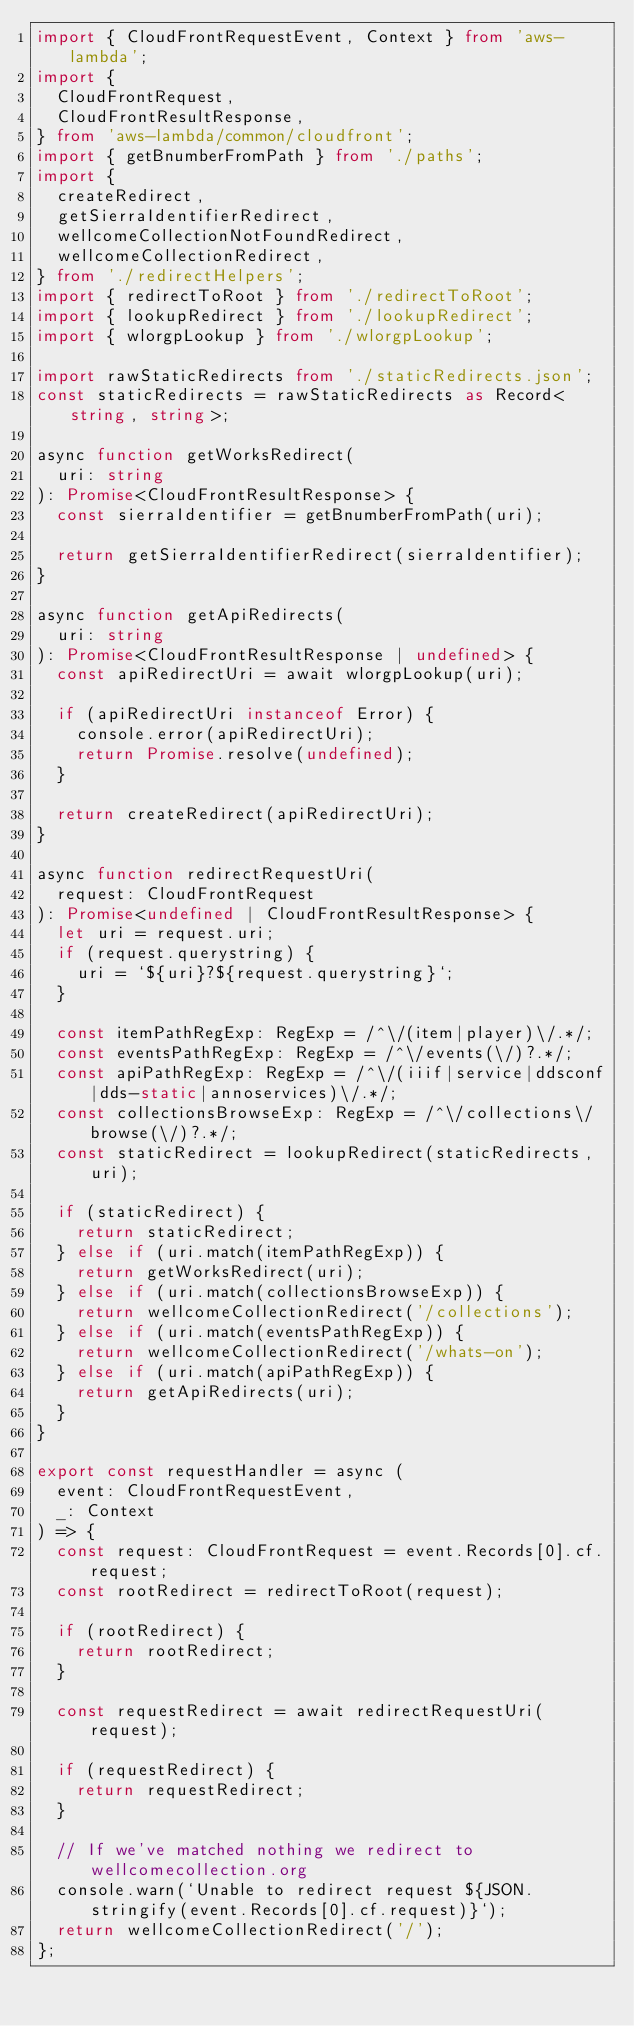Convert code to text. <code><loc_0><loc_0><loc_500><loc_500><_TypeScript_>import { CloudFrontRequestEvent, Context } from 'aws-lambda';
import {
  CloudFrontRequest,
  CloudFrontResultResponse,
} from 'aws-lambda/common/cloudfront';
import { getBnumberFromPath } from './paths';
import {
  createRedirect,
  getSierraIdentifierRedirect,
  wellcomeCollectionNotFoundRedirect,
  wellcomeCollectionRedirect,
} from './redirectHelpers';
import { redirectToRoot } from './redirectToRoot';
import { lookupRedirect } from './lookupRedirect';
import { wlorgpLookup } from './wlorgpLookup';

import rawStaticRedirects from './staticRedirects.json';
const staticRedirects = rawStaticRedirects as Record<string, string>;

async function getWorksRedirect(
  uri: string
): Promise<CloudFrontResultResponse> {
  const sierraIdentifier = getBnumberFromPath(uri);

  return getSierraIdentifierRedirect(sierraIdentifier);
}

async function getApiRedirects(
  uri: string
): Promise<CloudFrontResultResponse | undefined> {
  const apiRedirectUri = await wlorgpLookup(uri);

  if (apiRedirectUri instanceof Error) {
    console.error(apiRedirectUri);
    return Promise.resolve(undefined);
  }

  return createRedirect(apiRedirectUri);
}

async function redirectRequestUri(
  request: CloudFrontRequest
): Promise<undefined | CloudFrontResultResponse> {
  let uri = request.uri;
  if (request.querystring) {
    uri = `${uri}?${request.querystring}`;
  }

  const itemPathRegExp: RegExp = /^\/(item|player)\/.*/;
  const eventsPathRegExp: RegExp = /^\/events(\/)?.*/;
  const apiPathRegExp: RegExp = /^\/(iiif|service|ddsconf|dds-static|annoservices)\/.*/;
  const collectionsBrowseExp: RegExp = /^\/collections\/browse(\/)?.*/;
  const staticRedirect = lookupRedirect(staticRedirects, uri);

  if (staticRedirect) {
    return staticRedirect;
  } else if (uri.match(itemPathRegExp)) {
    return getWorksRedirect(uri);
  } else if (uri.match(collectionsBrowseExp)) {
    return wellcomeCollectionRedirect('/collections');
  } else if (uri.match(eventsPathRegExp)) {
    return wellcomeCollectionRedirect('/whats-on');
  } else if (uri.match(apiPathRegExp)) {
    return getApiRedirects(uri);
  }
}

export const requestHandler = async (
  event: CloudFrontRequestEvent,
  _: Context
) => {
  const request: CloudFrontRequest = event.Records[0].cf.request;
  const rootRedirect = redirectToRoot(request);

  if (rootRedirect) {
    return rootRedirect;
  }

  const requestRedirect = await redirectRequestUri(request);

  if (requestRedirect) {
    return requestRedirect;
  }

  // If we've matched nothing we redirect to wellcomecollection.org
  console.warn(`Unable to redirect request ${JSON.stringify(event.Records[0].cf.request)}`);
  return wellcomeCollectionRedirect('/');
};
</code> 